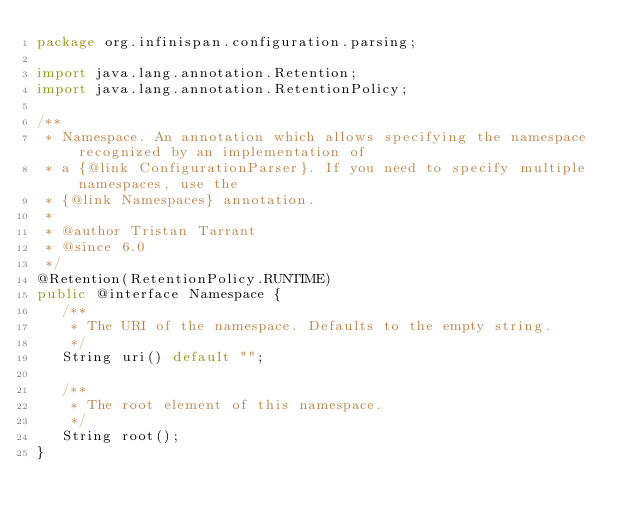<code> <loc_0><loc_0><loc_500><loc_500><_Java_>package org.infinispan.configuration.parsing;

import java.lang.annotation.Retention;
import java.lang.annotation.RetentionPolicy;

/**
 * Namespace. An annotation which allows specifying the namespace recognized by an implementation of
 * a {@link ConfigurationParser}. If you need to specify multiple namespaces, use the
 * {@link Namespaces} annotation.
 *
 * @author Tristan Tarrant
 * @since 6.0
 */
@Retention(RetentionPolicy.RUNTIME)
public @interface Namespace {
   /**
    * The URI of the namespace. Defaults to the empty string.
    */
   String uri() default "";

   /**
    * The root element of this namespace.
    */
   String root();
}
</code> 